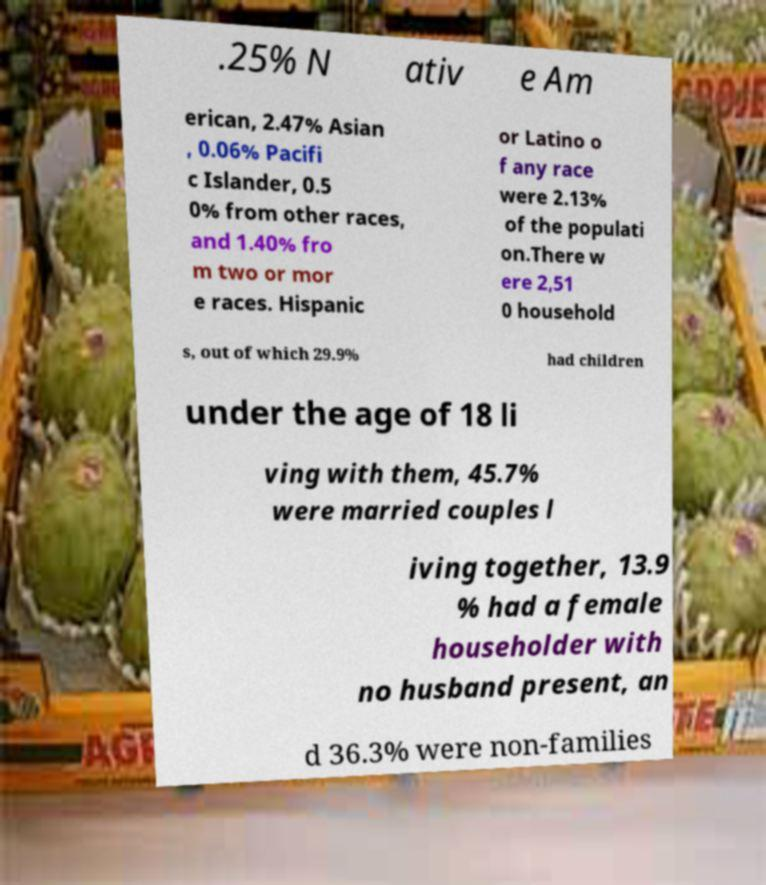What messages or text are displayed in this image? I need them in a readable, typed format. .25% N ativ e Am erican, 2.47% Asian , 0.06% Pacifi c Islander, 0.5 0% from other races, and 1.40% fro m two or mor e races. Hispanic or Latino o f any race were 2.13% of the populati on.There w ere 2,51 0 household s, out of which 29.9% had children under the age of 18 li ving with them, 45.7% were married couples l iving together, 13.9 % had a female householder with no husband present, an d 36.3% were non-families 